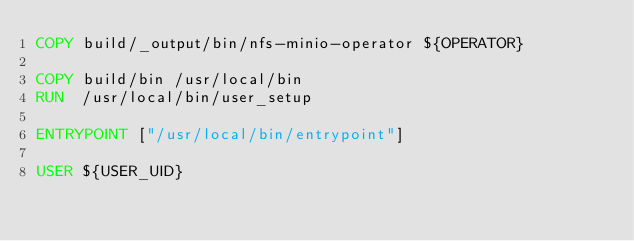Convert code to text. <code><loc_0><loc_0><loc_500><loc_500><_Dockerfile_>COPY build/_output/bin/nfs-minio-operator ${OPERATOR}

COPY build/bin /usr/local/bin
RUN  /usr/local/bin/user_setup

ENTRYPOINT ["/usr/local/bin/entrypoint"]

USER ${USER_UID}
</code> 